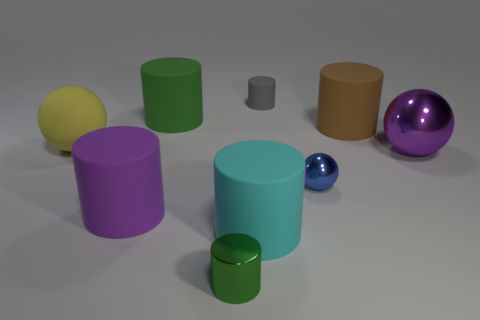Subtract all metallic spheres. How many spheres are left? 1 Subtract all gray cylinders. How many cylinders are left? 5 Subtract 4 cylinders. How many cylinders are left? 2 Add 1 brown rubber objects. How many objects exist? 10 Subtract all cylinders. How many objects are left? 3 Subtract all blue cylinders. Subtract all purple spheres. How many cylinders are left? 6 Add 4 blue balls. How many blue balls exist? 5 Subtract 0 red spheres. How many objects are left? 9 Subtract all purple metallic balls. Subtract all rubber balls. How many objects are left? 7 Add 5 big green rubber objects. How many big green rubber objects are left? 6 